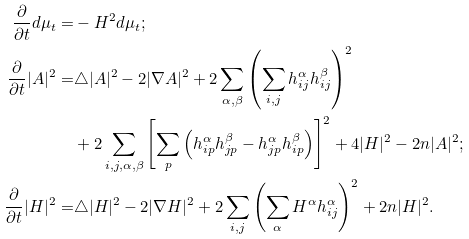<formula> <loc_0><loc_0><loc_500><loc_500>\frac { \partial } { \partial t } d \mu _ { t } = & - H ^ { 2 } d \mu _ { t } ; \\ \frac { \partial } { \partial t } | A | ^ { 2 } = & \triangle | A | ^ { 2 } - 2 | \nabla A | ^ { 2 } + 2 \sum _ { \alpha , \beta } \left ( \sum _ { i , j } h ^ { \alpha } _ { i j } h ^ { \beta } _ { i j } \right ) ^ { 2 } \\ & + 2 \sum _ { i , j , \alpha , \beta } \left [ \sum _ { p } \left ( h _ { i p } ^ { \alpha } h _ { j p } ^ { \beta } - h _ { j p } ^ { \alpha } h _ { i p } ^ { \beta } \right ) \right ] ^ { 2 } + 4 | H | ^ { 2 } - 2 n | A | ^ { 2 } ; \\ \frac { \partial } { \partial t } | H | ^ { 2 } = & \triangle | H | ^ { 2 } - 2 | \nabla H | ^ { 2 } + 2 \sum _ { i , j } \left ( \sum _ { \alpha } H ^ { \alpha } h ^ { \alpha } _ { i j } \right ) ^ { 2 } + 2 n | H | ^ { 2 } .</formula> 